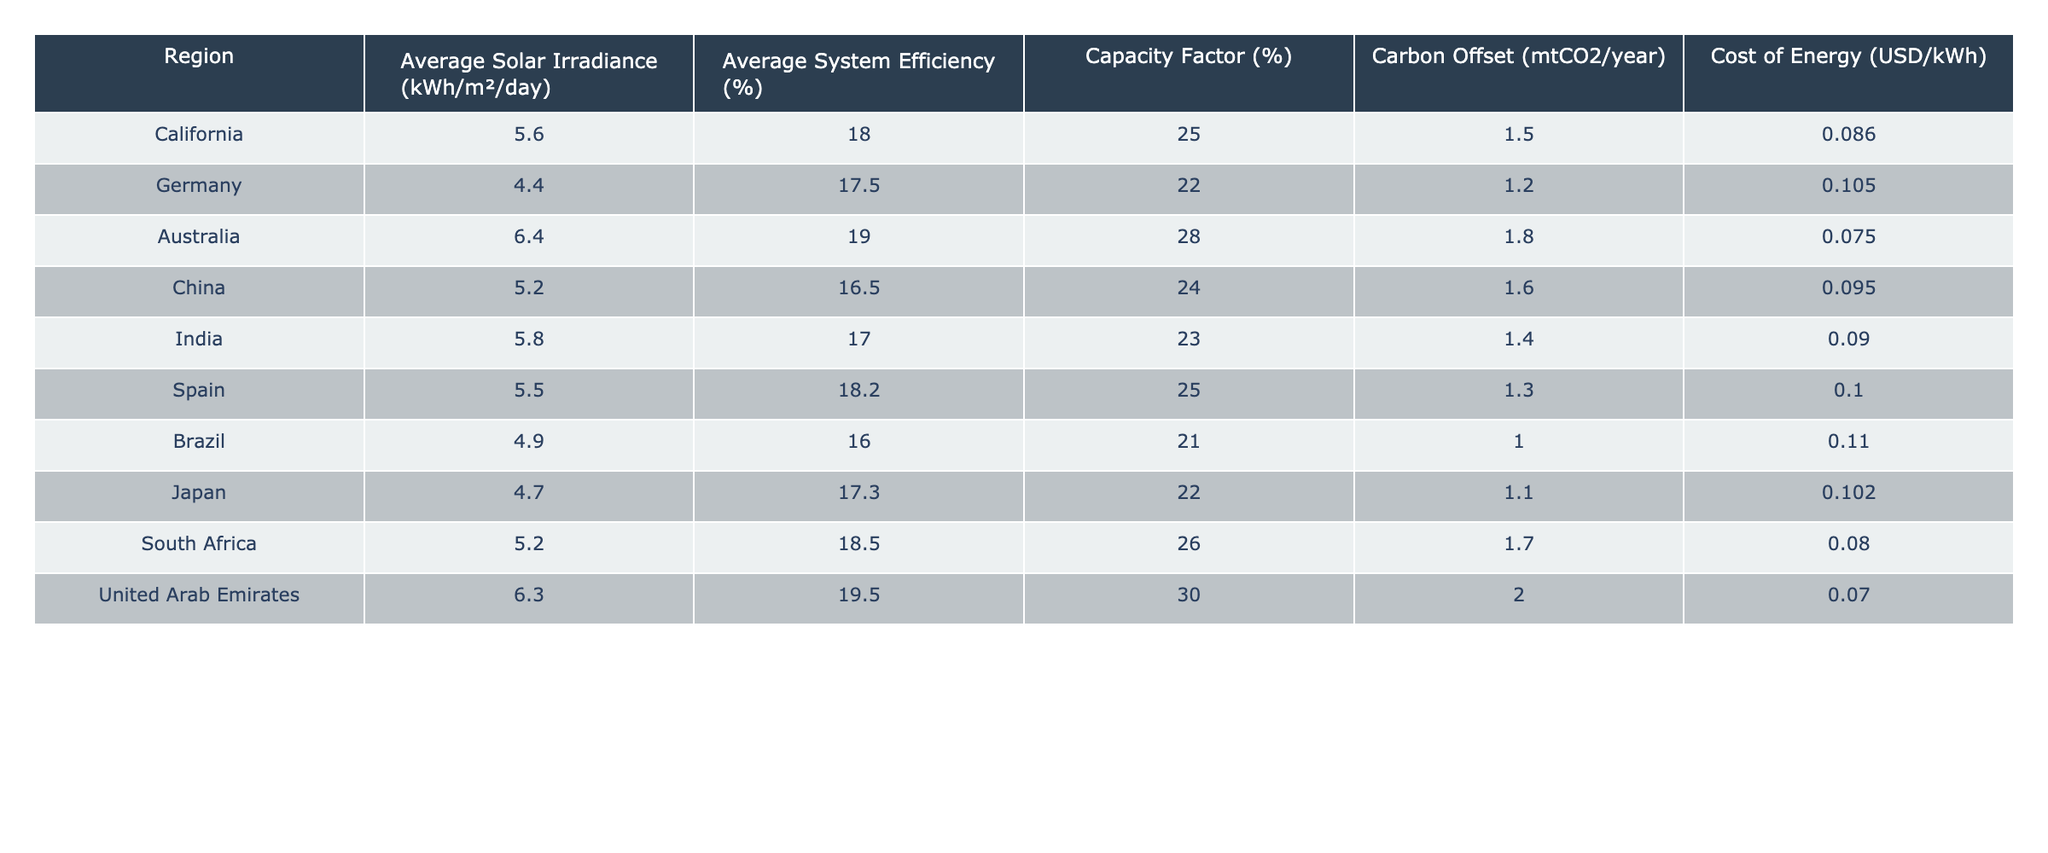What is the carbon offset for the United Arab Emirates? The carbon offset value in the United Arab Emirates row of the table is 2.0 mtCO2/year.
Answer: 2.0 Which region has the highest average system efficiency? By reviewing the table, the region with the highest average system efficiency is the United Arab Emirates with 19.5%.
Answer: United Arab Emirates What is the average cost of energy across all regions? To find the average cost of energy, we sum the costs of energy from all regions: (0.086 + 0.105 + 0.075 + 0.095 + 0.090 + 0.100 + 0.110 + 0.102 + 0.080 + 0.070) = 1.021. There are 10 regions, so the average is 1.021 / 10 = 0.1021.
Answer: 0.1021 Is the average solar irradiance in Australia higher than in California? The average solar irradiance in Australia is 6.4 kWh/m²/day, while in California, it is 5.6 kWh/m²/day. Since 6.4 > 5.6, the statement is true.
Answer: Yes Which regions have a capacity factor greater than 25%? The regions with a capacity factor greater than 25% are Australia (28%), United Arab Emirates (30%), and South Africa (26%). This involves checking the capacity factor column and identifying which values exceed 25%.
Answer: Australia, United Arab Emirates, South Africa What is the difference in carbon offset between Australia and Brazil? Australia has a carbon offset of 1.8 mtCO2/year, and Brazil has 1.0 mtCO2/year. The difference is calculated by subtracting Brazil's value from Australia's: 1.8 - 1.0 = 0.8 mtCO2/year.
Answer: 0.8 mtCO2/year Which region has the lowest cost of energy? By looking at the cost of energy in the table, Brazil has a cost of energy of 0.110 USD/kWh, which is the highest. The lowest is in the United Arab Emirates at 0.070 USD/kWh.
Answer: United Arab Emirates Are there any regions with an average solar irradiance below 5.0 kWh/m²/day? The regions listed in the table all have solar irradiance values above 5.0 kWh/m²/day, as the lowest is California at 5.6 kWh/m²/day. Therefore, the answer is no.
Answer: No What region has the highest average solar irradiance and what is that value? By examining the table, Australia's average solar irradiance is 6.4 kWh/m²/day, which is the highest among all regions.
Answer: Australia, 6.4 kWh/m²/day 